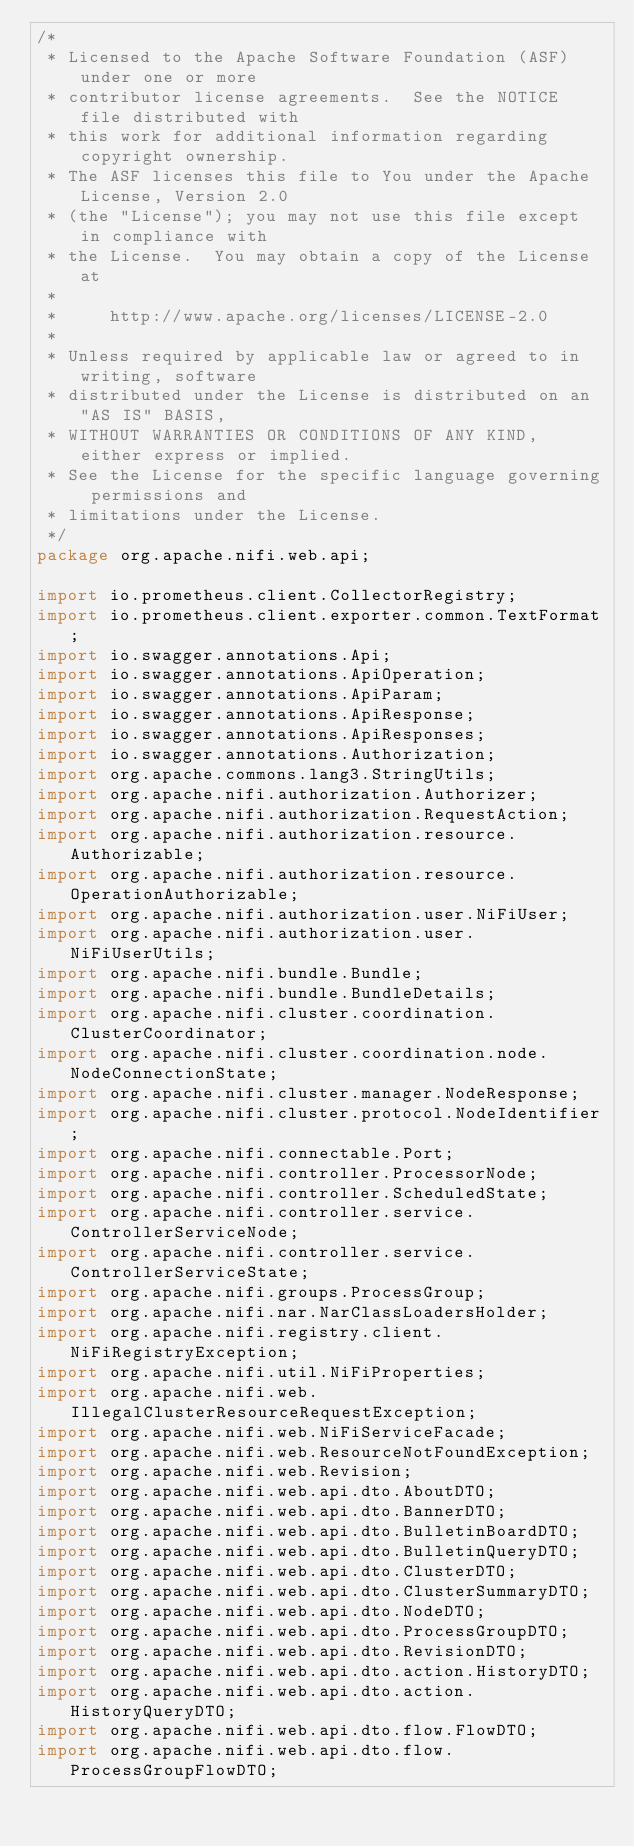<code> <loc_0><loc_0><loc_500><loc_500><_Java_>/*
 * Licensed to the Apache Software Foundation (ASF) under one or more
 * contributor license agreements.  See the NOTICE file distributed with
 * this work for additional information regarding copyright ownership.
 * The ASF licenses this file to You under the Apache License, Version 2.0
 * (the "License"); you may not use this file except in compliance with
 * the License.  You may obtain a copy of the License at
 *
 *     http://www.apache.org/licenses/LICENSE-2.0
 *
 * Unless required by applicable law or agreed to in writing, software
 * distributed under the License is distributed on an "AS IS" BASIS,
 * WITHOUT WARRANTIES OR CONDITIONS OF ANY KIND, either express or implied.
 * See the License for the specific language governing permissions and
 * limitations under the License.
 */
package org.apache.nifi.web.api;

import io.prometheus.client.CollectorRegistry;
import io.prometheus.client.exporter.common.TextFormat;
import io.swagger.annotations.Api;
import io.swagger.annotations.ApiOperation;
import io.swagger.annotations.ApiParam;
import io.swagger.annotations.ApiResponse;
import io.swagger.annotations.ApiResponses;
import io.swagger.annotations.Authorization;
import org.apache.commons.lang3.StringUtils;
import org.apache.nifi.authorization.Authorizer;
import org.apache.nifi.authorization.RequestAction;
import org.apache.nifi.authorization.resource.Authorizable;
import org.apache.nifi.authorization.resource.OperationAuthorizable;
import org.apache.nifi.authorization.user.NiFiUser;
import org.apache.nifi.authorization.user.NiFiUserUtils;
import org.apache.nifi.bundle.Bundle;
import org.apache.nifi.bundle.BundleDetails;
import org.apache.nifi.cluster.coordination.ClusterCoordinator;
import org.apache.nifi.cluster.coordination.node.NodeConnectionState;
import org.apache.nifi.cluster.manager.NodeResponse;
import org.apache.nifi.cluster.protocol.NodeIdentifier;
import org.apache.nifi.connectable.Port;
import org.apache.nifi.controller.ProcessorNode;
import org.apache.nifi.controller.ScheduledState;
import org.apache.nifi.controller.service.ControllerServiceNode;
import org.apache.nifi.controller.service.ControllerServiceState;
import org.apache.nifi.groups.ProcessGroup;
import org.apache.nifi.nar.NarClassLoadersHolder;
import org.apache.nifi.registry.client.NiFiRegistryException;
import org.apache.nifi.util.NiFiProperties;
import org.apache.nifi.web.IllegalClusterResourceRequestException;
import org.apache.nifi.web.NiFiServiceFacade;
import org.apache.nifi.web.ResourceNotFoundException;
import org.apache.nifi.web.Revision;
import org.apache.nifi.web.api.dto.AboutDTO;
import org.apache.nifi.web.api.dto.BannerDTO;
import org.apache.nifi.web.api.dto.BulletinBoardDTO;
import org.apache.nifi.web.api.dto.BulletinQueryDTO;
import org.apache.nifi.web.api.dto.ClusterDTO;
import org.apache.nifi.web.api.dto.ClusterSummaryDTO;
import org.apache.nifi.web.api.dto.NodeDTO;
import org.apache.nifi.web.api.dto.ProcessGroupDTO;
import org.apache.nifi.web.api.dto.RevisionDTO;
import org.apache.nifi.web.api.dto.action.HistoryDTO;
import org.apache.nifi.web.api.dto.action.HistoryQueryDTO;
import org.apache.nifi.web.api.dto.flow.FlowDTO;
import org.apache.nifi.web.api.dto.flow.ProcessGroupFlowDTO;</code> 